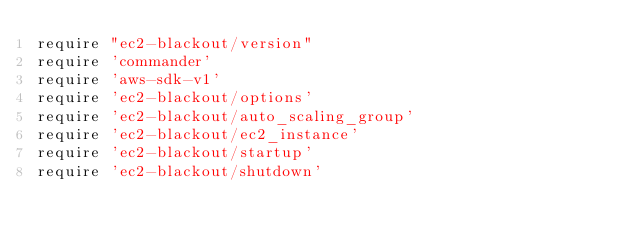Convert code to text. <code><loc_0><loc_0><loc_500><loc_500><_Ruby_>require "ec2-blackout/version"
require 'commander'
require 'aws-sdk-v1'
require 'ec2-blackout/options'
require 'ec2-blackout/auto_scaling_group'
require 'ec2-blackout/ec2_instance'
require 'ec2-blackout/startup'
require 'ec2-blackout/shutdown'
</code> 